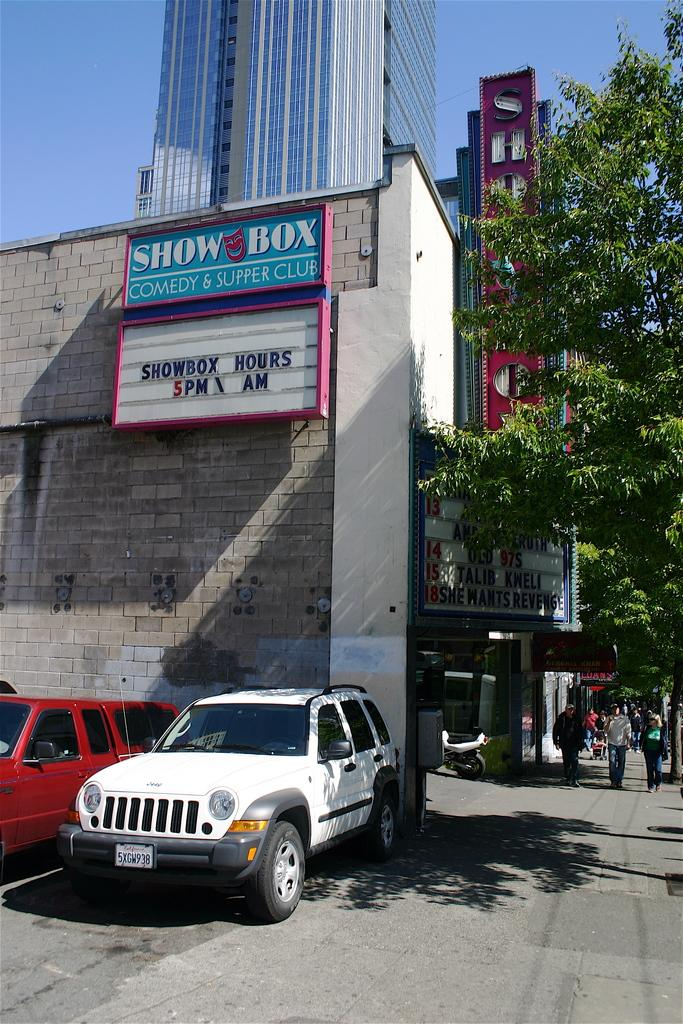<image>
Create a compact narrative representing the image presented. The Show Box comedy and supper club opens at 5 pm according to their sign. 